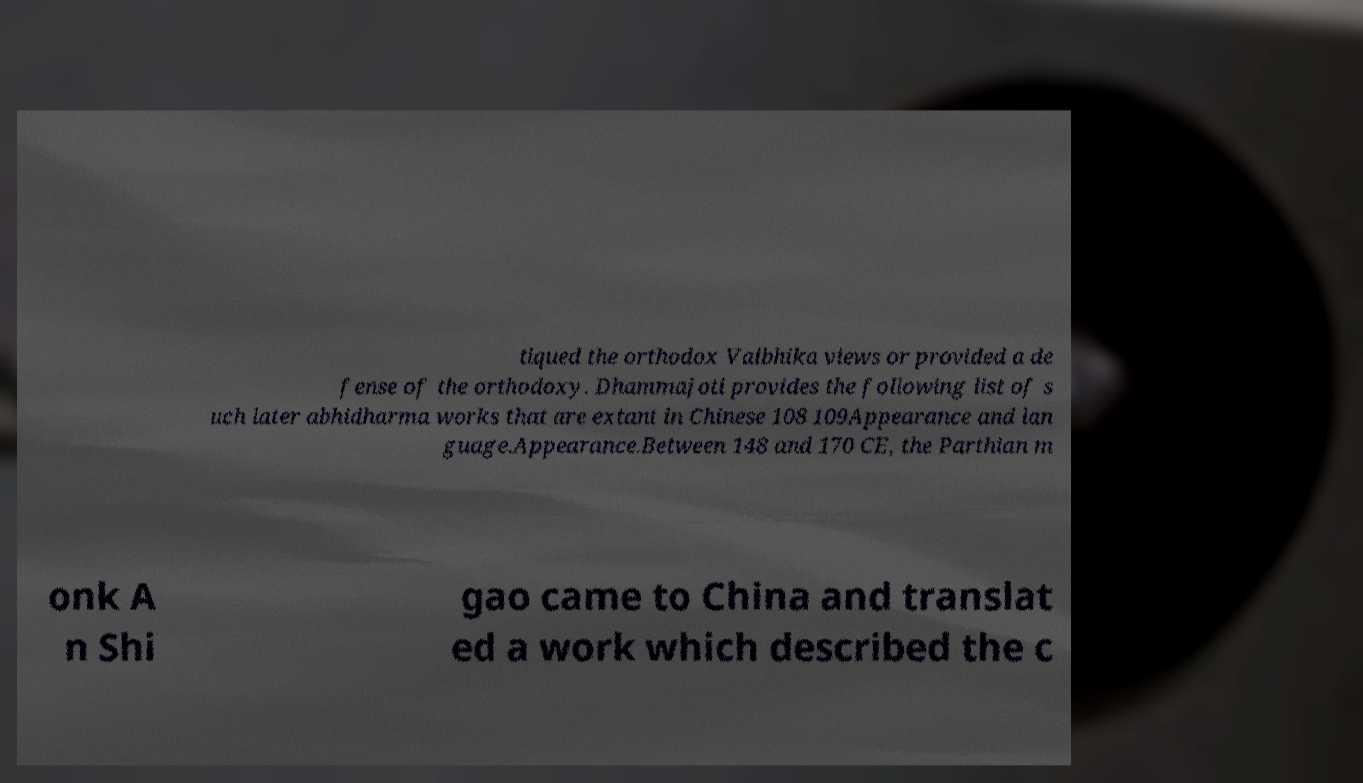What messages or text are displayed in this image? I need them in a readable, typed format. tiqued the orthodox Vaibhika views or provided a de fense of the orthodoxy. Dhammajoti provides the following list of s uch later abhidharma works that are extant in Chinese 108 109Appearance and lan guage.Appearance.Between 148 and 170 CE, the Parthian m onk A n Shi gao came to China and translat ed a work which described the c 